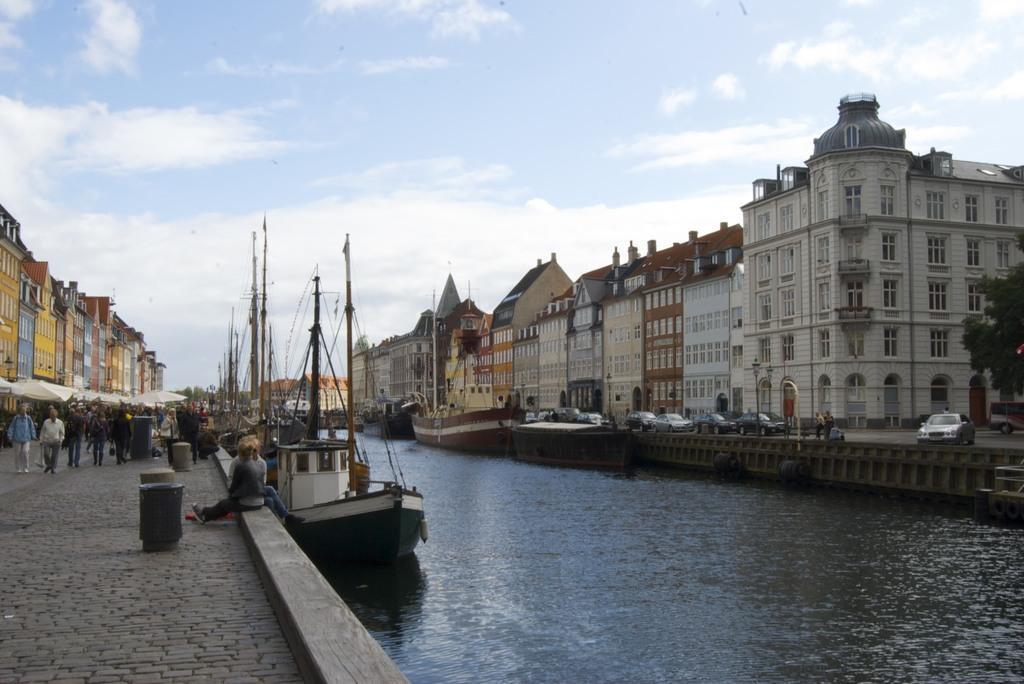Can you describe this image briefly? In this image we can see there are few boats sailing on the river. On the either sides of the river there are buildings, in front of the building there are few people walking on the pavement. On the right side there are few vehicles are parked on the pavement. In the background there is a sky. 